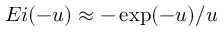<formula> <loc_0><loc_0><loc_500><loc_500>E i ( - u ) \approx - \exp ( - u ) / u</formula> 